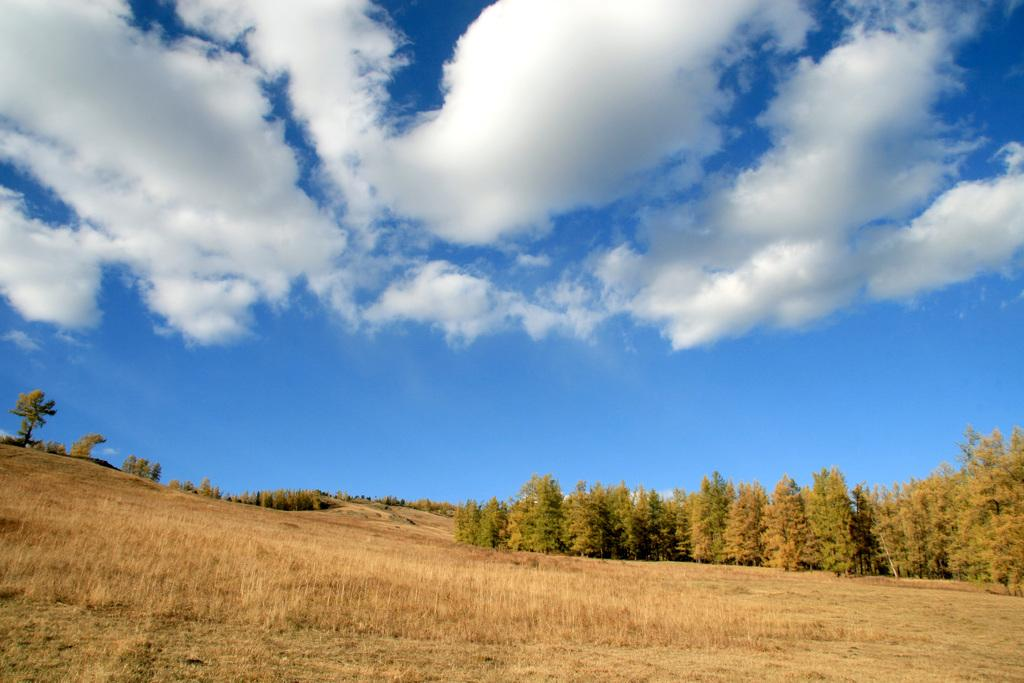What type of vegetation is on the ground in the image? There is grass on the ground in the image. What other natural elements can be seen in the image? There are trees in the image. What is visible at the top of the image? The sky is visible at the top of the image. What can be observed in the sky? Clouds are present in the sky. How many brothers does the stranger in the image have? There is no stranger or mention of brothers in the image. What is the writer doing in the image? There is no writer present in the image. 